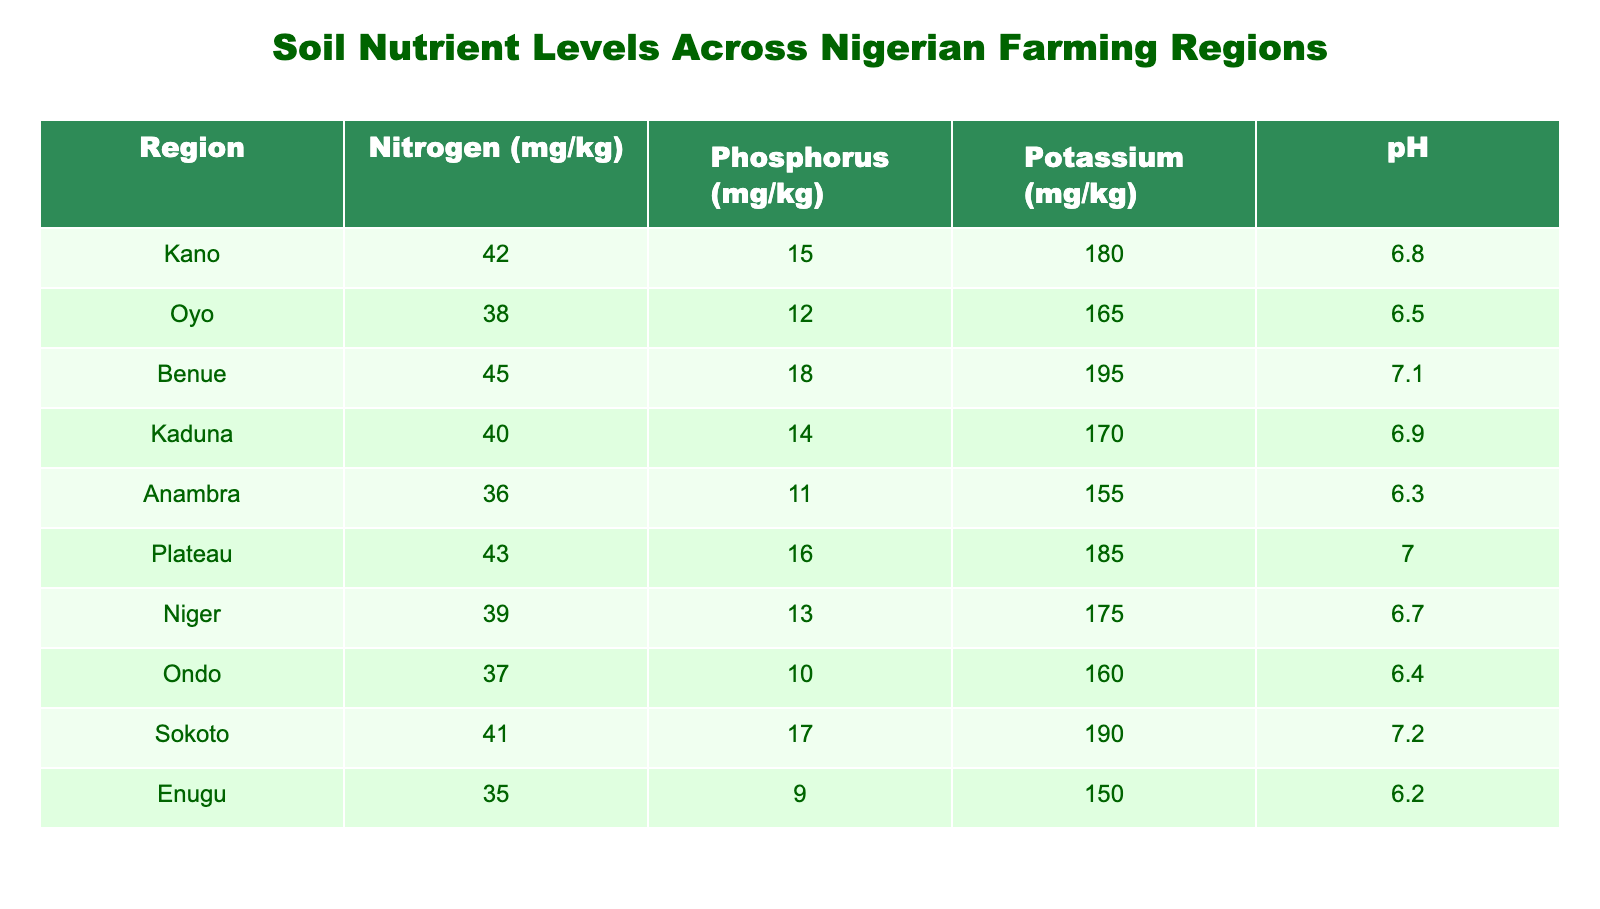What is the nitrogen level in the Sokoto region? The table lists the nitrogen level for the Sokoto region, which is stated directly in the corresponding row. The value is 41 mg/kg.
Answer: 41 mg/kg Which region has the highest phosphorus level? By scanning through the phosphorus column, the region with the highest value is Benue, which shows a level of 18 mg/kg.
Answer: Benue What is the average potassium level across all regions? To find the average, we first sum the potassium levels from all regions: (180 + 165 + 195 + 170 + 155 + 185 + 175 + 160 + 190 + 150) = 1685. Then we divide by the number of regions, which is 10: 1685 / 10 = 168.5.
Answer: 168.5 mg/kg Is the pH level in Anambra above 6? Checking the pH value in the Anambra row, we find it is 6.3, which is less than 6. Therefore, the statement is false.
Answer: No Which region has both the highest potassium and the highest pH level? The maximum values for potassium and pH must be identified separately. The highest potassium level is 195 mg/kg in Benue and the highest pH level is 7.2 in Sokoto. Since these are in different regions, there is no single region that meets both criteria.
Answer: None What is the difference in nitrogen levels between Kano and Oyo? The nitrogen level in Kano is 42 mg/kg and in Oyo it is 38 mg/kg. The difference is calculated by subtracting Oyo's level from Kano's level: 42 - 38 = 4.
Answer: 4 mg/kg Are nitrogen levels higher in Niger than in Anambra? By comparing the nitrogen levels in the two regions, Niger has 39 mg/kg and Anambra has 36 mg/kg. Since 39 is greater than 36, the statement is true.
Answer: Yes Which region has a pH level lower than 6.5 and its phosphorus level higher than 12? Scanning both columns, we find Anambra (pH of 6.3 and phosphorus of 11), Ondo (pH of 6.4 and phosphorus of 10), and Enugu (pH of 6.2 and phosphorus of 9). None of these has both criteria satisfied. Hence, no such region exists.
Answer: None 